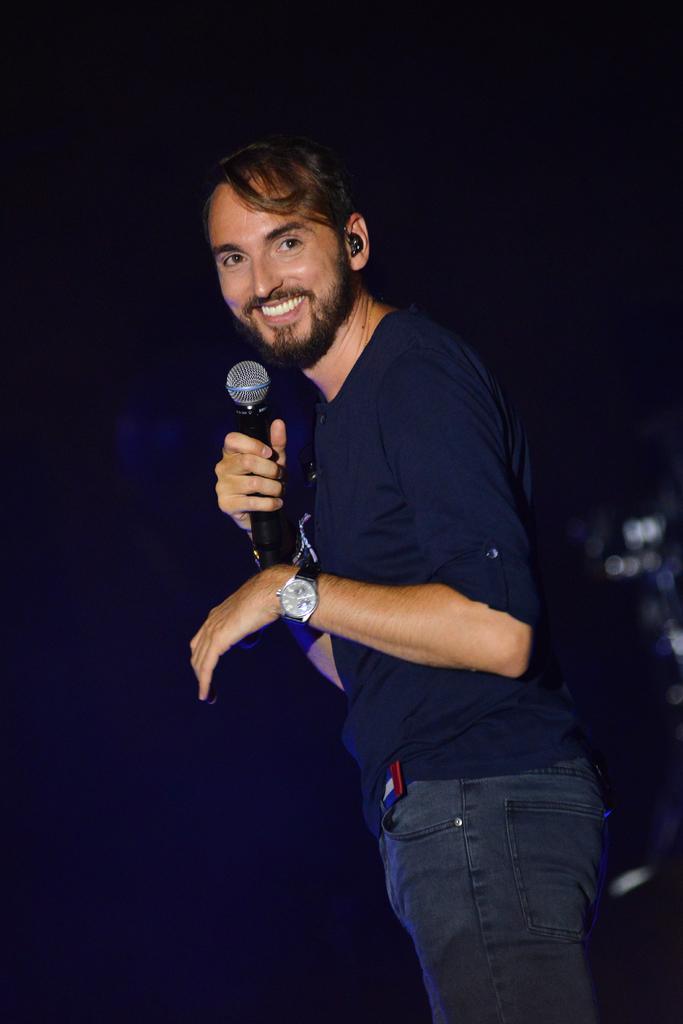Can you describe this image briefly? In this image I can see a person standing and the person is wearing blue shirt, gray pant and holding a microphone and I can see dark background. 